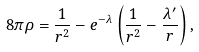Convert formula to latex. <formula><loc_0><loc_0><loc_500><loc_500>8 \pi \rho = \frac { 1 } { r ^ { 2 } } - e ^ { - \lambda } \left ( \frac { 1 } { r ^ { 2 } } - \frac { \lambda ^ { \prime } } { r } \right ) ,</formula> 